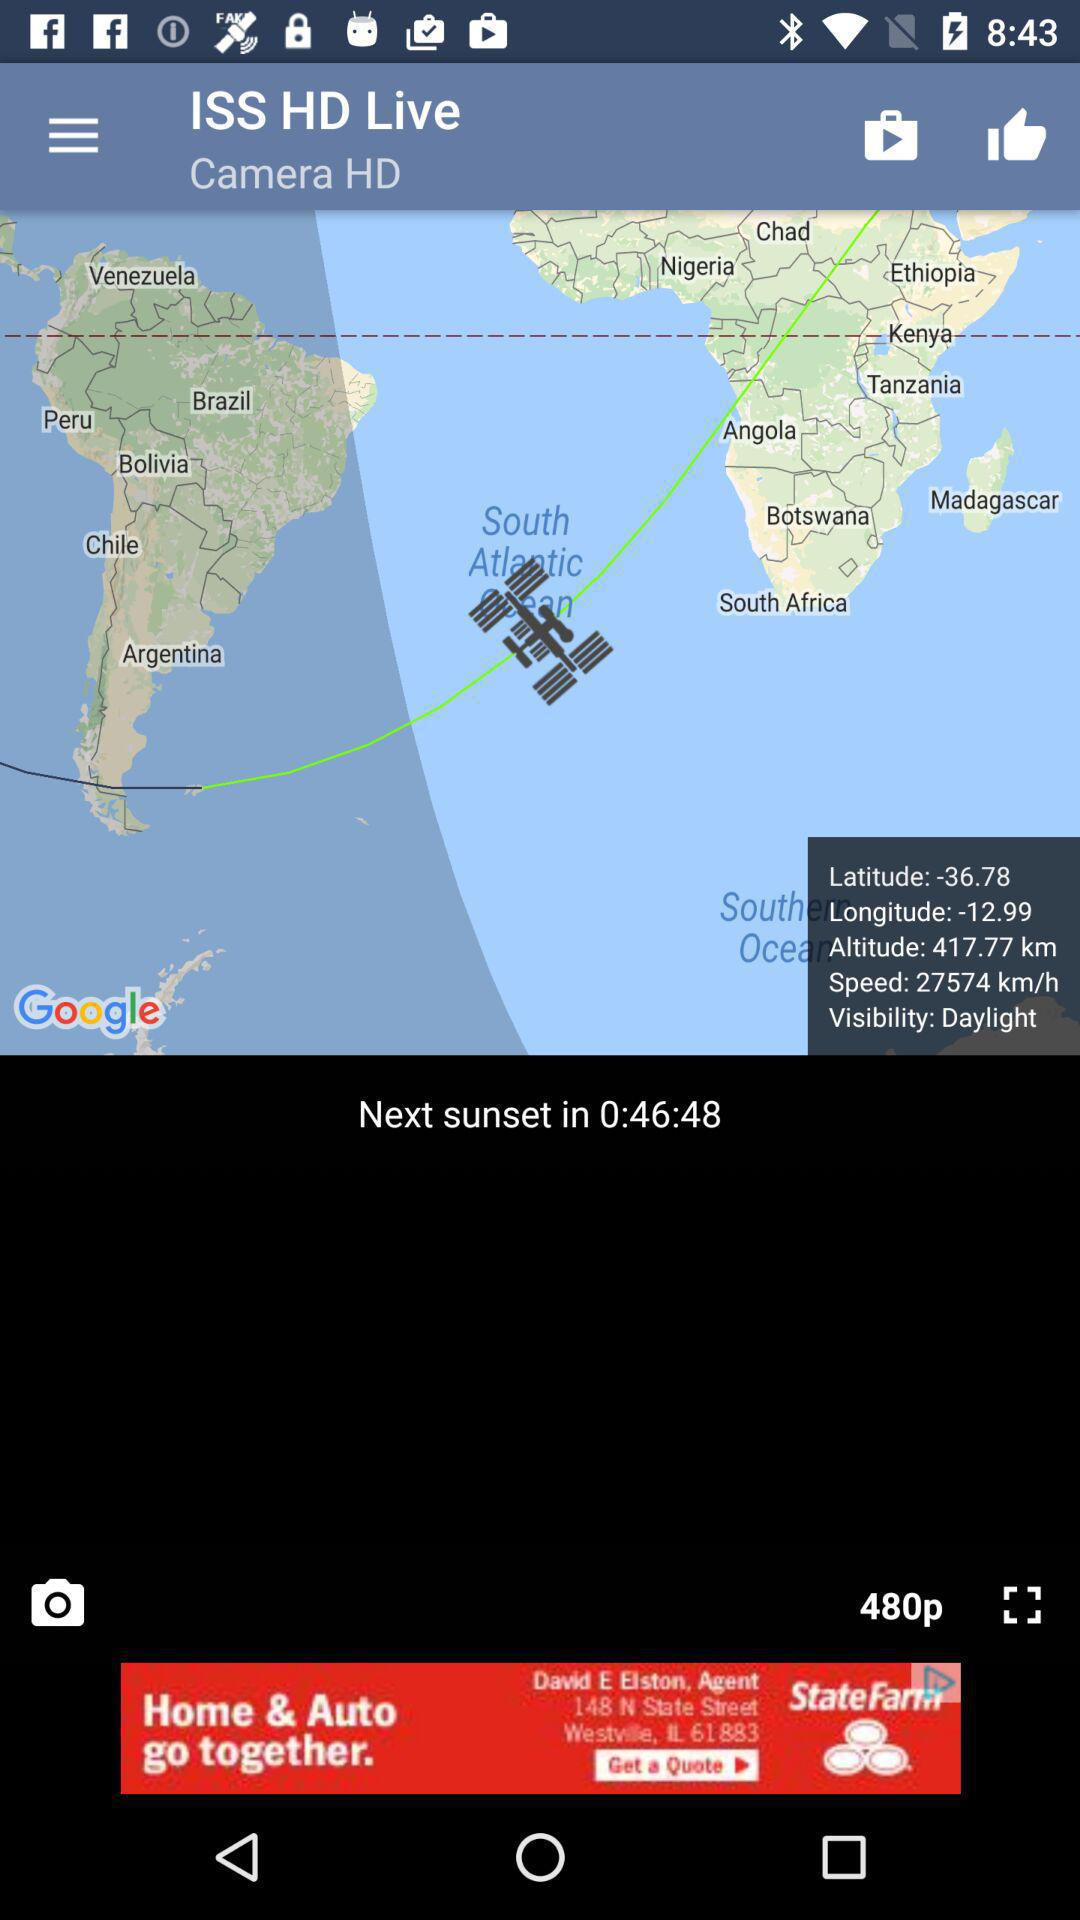What is the visibility? The visibility is daylight. 